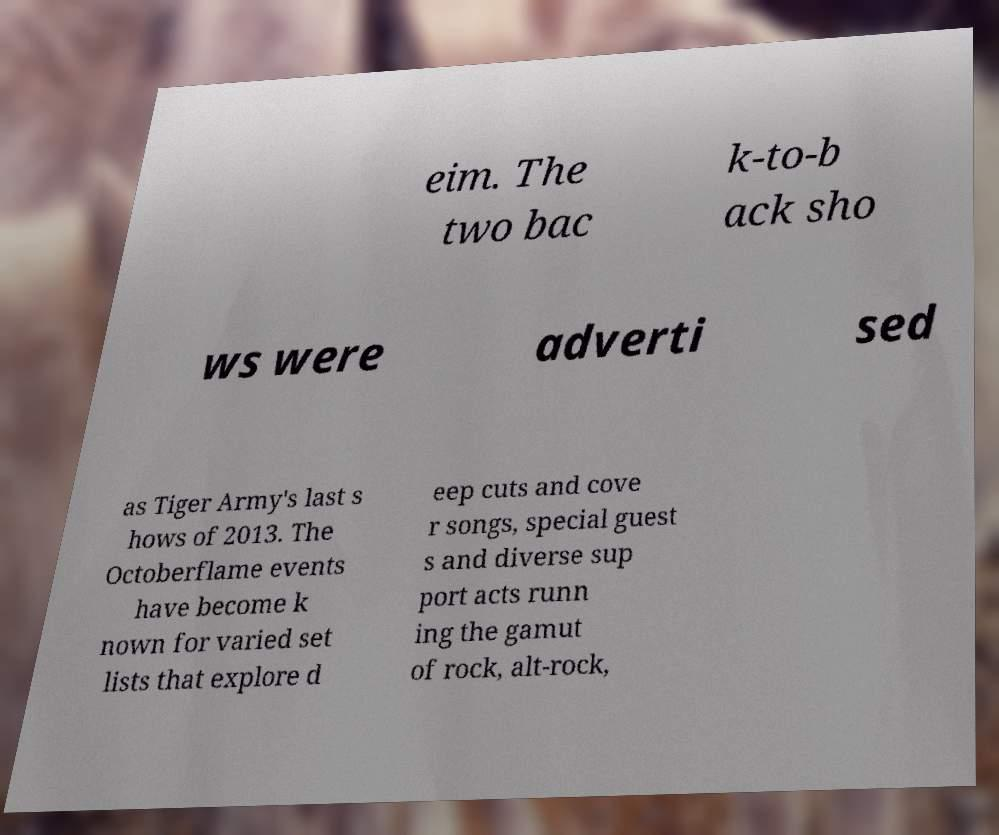Could you assist in decoding the text presented in this image and type it out clearly? eim. The two bac k-to-b ack sho ws were adverti sed as Tiger Army's last s hows of 2013. The Octoberflame events have become k nown for varied set lists that explore d eep cuts and cove r songs, special guest s and diverse sup port acts runn ing the gamut of rock, alt-rock, 